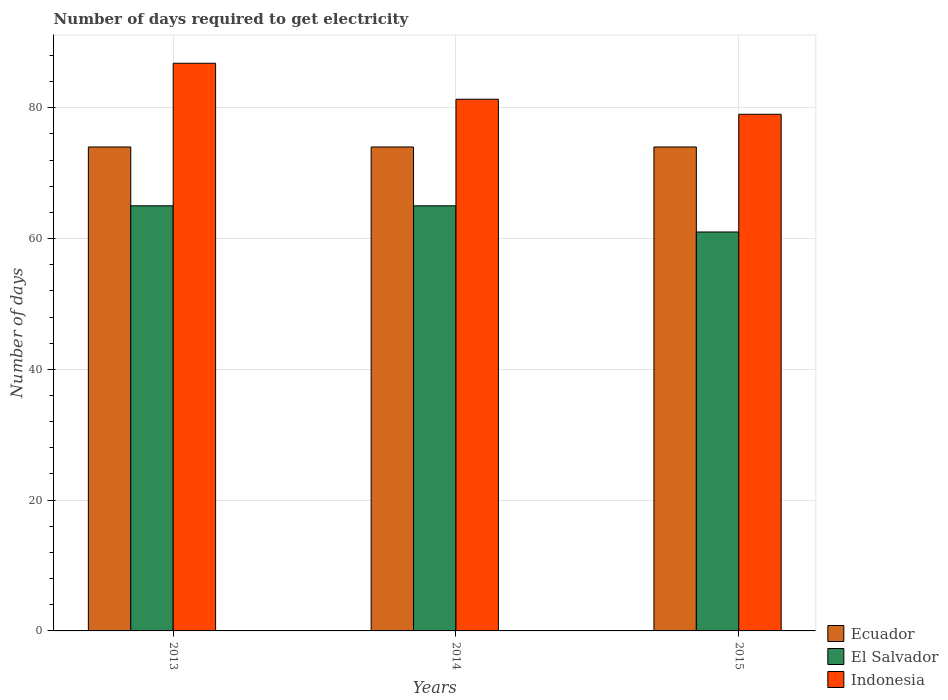How many groups of bars are there?
Your answer should be compact. 3. Are the number of bars per tick equal to the number of legend labels?
Your response must be concise. Yes. What is the label of the 3rd group of bars from the left?
Offer a very short reply. 2015. What is the number of days required to get electricity in in El Salvador in 2013?
Your answer should be very brief. 65. Across all years, what is the maximum number of days required to get electricity in in El Salvador?
Give a very brief answer. 65. Across all years, what is the minimum number of days required to get electricity in in Ecuador?
Provide a short and direct response. 74. In which year was the number of days required to get electricity in in Indonesia maximum?
Make the answer very short. 2013. In which year was the number of days required to get electricity in in Indonesia minimum?
Give a very brief answer. 2015. What is the total number of days required to get electricity in in Indonesia in the graph?
Your answer should be compact. 247.1. What is the difference between the number of days required to get electricity in in Indonesia in 2014 and the number of days required to get electricity in in Ecuador in 2013?
Your response must be concise. 7.3. What is the average number of days required to get electricity in in Indonesia per year?
Offer a terse response. 82.37. In the year 2014, what is the difference between the number of days required to get electricity in in Indonesia and number of days required to get electricity in in Ecuador?
Provide a succinct answer. 7.3. In how many years, is the number of days required to get electricity in in Indonesia greater than 68 days?
Keep it short and to the point. 3. What is the ratio of the number of days required to get electricity in in Indonesia in 2013 to that in 2015?
Your answer should be compact. 1.1. Is the difference between the number of days required to get electricity in in Indonesia in 2013 and 2015 greater than the difference between the number of days required to get electricity in in Ecuador in 2013 and 2015?
Ensure brevity in your answer.  Yes. What does the 1st bar from the left in 2013 represents?
Offer a terse response. Ecuador. What does the 3rd bar from the right in 2013 represents?
Keep it short and to the point. Ecuador. How many bars are there?
Give a very brief answer. 9. How many years are there in the graph?
Make the answer very short. 3. Are the values on the major ticks of Y-axis written in scientific E-notation?
Make the answer very short. No. Does the graph contain any zero values?
Your response must be concise. No. Does the graph contain grids?
Give a very brief answer. Yes. Where does the legend appear in the graph?
Keep it short and to the point. Bottom right. What is the title of the graph?
Keep it short and to the point. Number of days required to get electricity. What is the label or title of the X-axis?
Make the answer very short. Years. What is the label or title of the Y-axis?
Keep it short and to the point. Number of days. What is the Number of days in Ecuador in 2013?
Ensure brevity in your answer.  74. What is the Number of days of Indonesia in 2013?
Your answer should be very brief. 86.8. What is the Number of days of Ecuador in 2014?
Your answer should be very brief. 74. What is the Number of days of Indonesia in 2014?
Make the answer very short. 81.3. What is the Number of days of El Salvador in 2015?
Offer a terse response. 61. What is the Number of days in Indonesia in 2015?
Keep it short and to the point. 79. Across all years, what is the maximum Number of days in El Salvador?
Your response must be concise. 65. Across all years, what is the maximum Number of days of Indonesia?
Your answer should be compact. 86.8. Across all years, what is the minimum Number of days of Ecuador?
Provide a succinct answer. 74. Across all years, what is the minimum Number of days of El Salvador?
Your answer should be compact. 61. Across all years, what is the minimum Number of days of Indonesia?
Offer a very short reply. 79. What is the total Number of days of Ecuador in the graph?
Offer a very short reply. 222. What is the total Number of days of El Salvador in the graph?
Offer a terse response. 191. What is the total Number of days in Indonesia in the graph?
Provide a short and direct response. 247.1. What is the difference between the Number of days in El Salvador in 2013 and that in 2015?
Your answer should be compact. 4. What is the difference between the Number of days in Indonesia in 2013 and that in 2015?
Offer a terse response. 7.8. What is the difference between the Number of days in El Salvador in 2014 and that in 2015?
Keep it short and to the point. 4. What is the difference between the Number of days in Indonesia in 2014 and that in 2015?
Offer a terse response. 2.3. What is the difference between the Number of days of Ecuador in 2013 and the Number of days of El Salvador in 2014?
Provide a short and direct response. 9. What is the difference between the Number of days of Ecuador in 2013 and the Number of days of Indonesia in 2014?
Provide a succinct answer. -7.3. What is the difference between the Number of days of El Salvador in 2013 and the Number of days of Indonesia in 2014?
Provide a short and direct response. -16.3. What is the difference between the Number of days of Ecuador in 2013 and the Number of days of Indonesia in 2015?
Provide a short and direct response. -5. What is the difference between the Number of days in El Salvador in 2013 and the Number of days in Indonesia in 2015?
Your response must be concise. -14. What is the average Number of days in El Salvador per year?
Give a very brief answer. 63.67. What is the average Number of days of Indonesia per year?
Your answer should be very brief. 82.37. In the year 2013, what is the difference between the Number of days in El Salvador and Number of days in Indonesia?
Provide a short and direct response. -21.8. In the year 2014, what is the difference between the Number of days in Ecuador and Number of days in El Salvador?
Your response must be concise. 9. In the year 2014, what is the difference between the Number of days of El Salvador and Number of days of Indonesia?
Your response must be concise. -16.3. In the year 2015, what is the difference between the Number of days of Ecuador and Number of days of El Salvador?
Offer a terse response. 13. In the year 2015, what is the difference between the Number of days in El Salvador and Number of days in Indonesia?
Keep it short and to the point. -18. What is the ratio of the Number of days in El Salvador in 2013 to that in 2014?
Give a very brief answer. 1. What is the ratio of the Number of days in Indonesia in 2013 to that in 2014?
Provide a short and direct response. 1.07. What is the ratio of the Number of days in El Salvador in 2013 to that in 2015?
Your response must be concise. 1.07. What is the ratio of the Number of days of Indonesia in 2013 to that in 2015?
Give a very brief answer. 1.1. What is the ratio of the Number of days of El Salvador in 2014 to that in 2015?
Provide a succinct answer. 1.07. What is the ratio of the Number of days of Indonesia in 2014 to that in 2015?
Keep it short and to the point. 1.03. What is the difference between the highest and the lowest Number of days in Ecuador?
Offer a terse response. 0. What is the difference between the highest and the lowest Number of days of Indonesia?
Provide a succinct answer. 7.8. 